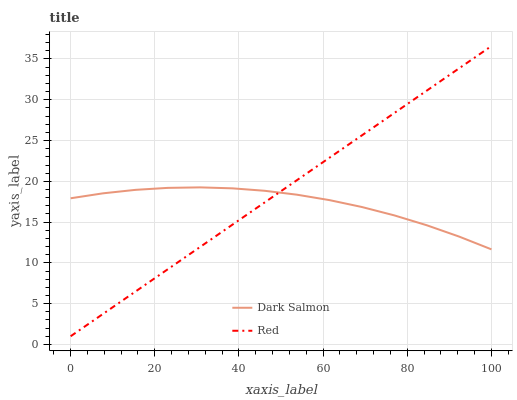Does Dark Salmon have the minimum area under the curve?
Answer yes or no. Yes. Does Red have the maximum area under the curve?
Answer yes or no. Yes. Does Red have the minimum area under the curve?
Answer yes or no. No. Is Red the smoothest?
Answer yes or no. Yes. Is Dark Salmon the roughest?
Answer yes or no. Yes. Is Red the roughest?
Answer yes or no. No. Does Red have the lowest value?
Answer yes or no. Yes. Does Red have the highest value?
Answer yes or no. Yes. Does Dark Salmon intersect Red?
Answer yes or no. Yes. Is Dark Salmon less than Red?
Answer yes or no. No. Is Dark Salmon greater than Red?
Answer yes or no. No. 